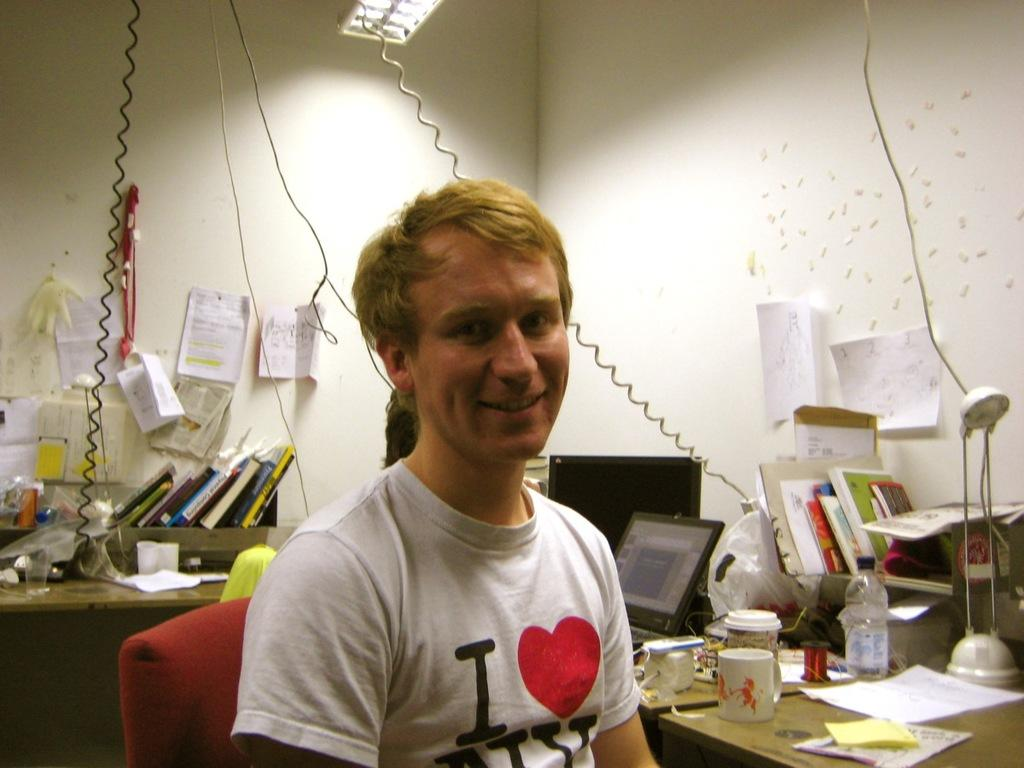Provide a one-sentence caption for the provided image. "I love NY" is printed on the front of this gentleman's t shirt. 